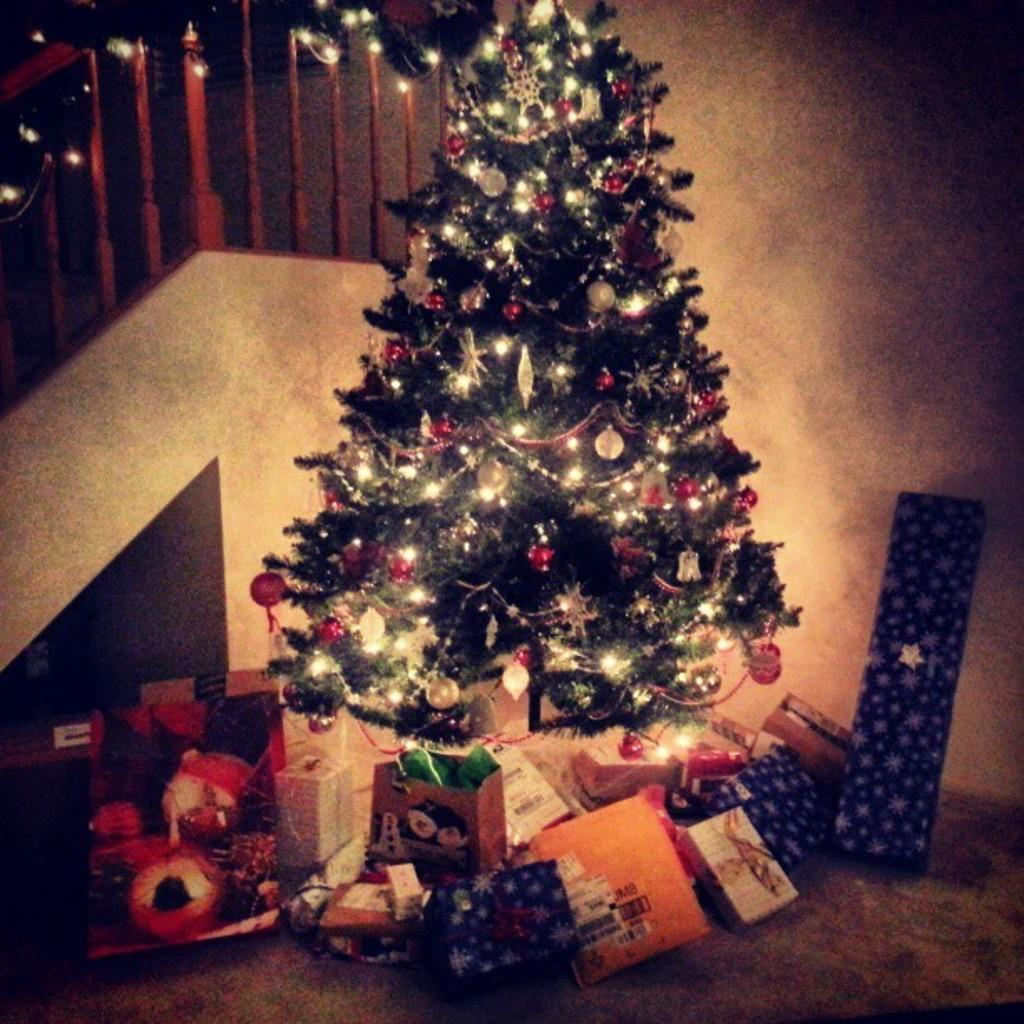What is the main object in the image? There is a Christmas tree in the image. How is the Christmas tree decorated? The Christmas tree is decorated with lights. What else can be seen near the Christmas tree? There are gift boxes near the Christmas tree. What architectural feature is located beside the Christmas tree? There is a staircase beside the Christmas tree. What type of camera is hanging from the Christmas tree in the image? There is no camera hanging from the Christmas tree in the image. How many buckets are used to decorate the Christmas tree in the image? There are no buckets used to decorate the Christmas tree in the image; it is decorated with lights. 